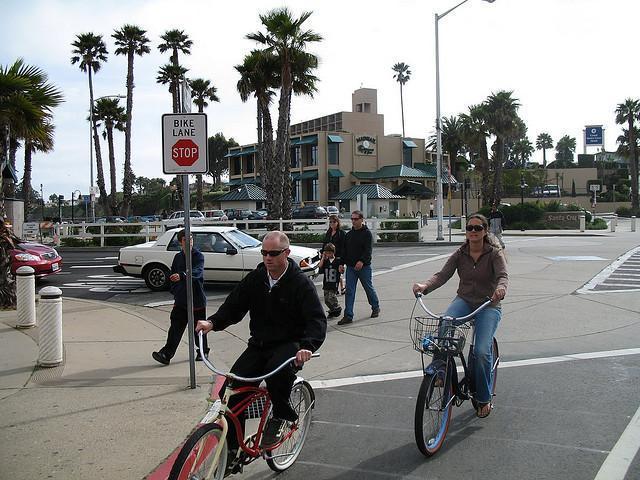How many people can you see?
Give a very brief answer. 4. How many bicycles can you see?
Give a very brief answer. 2. How many giraffes are there?
Give a very brief answer. 0. 